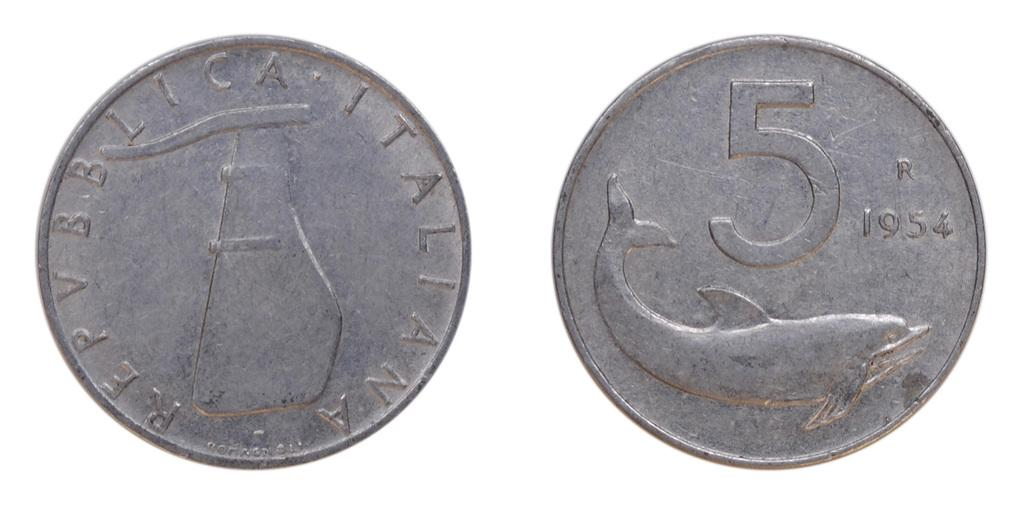Provide a one-sentence caption for the provided image. two, 5 cent italian coins from the year 1954. 